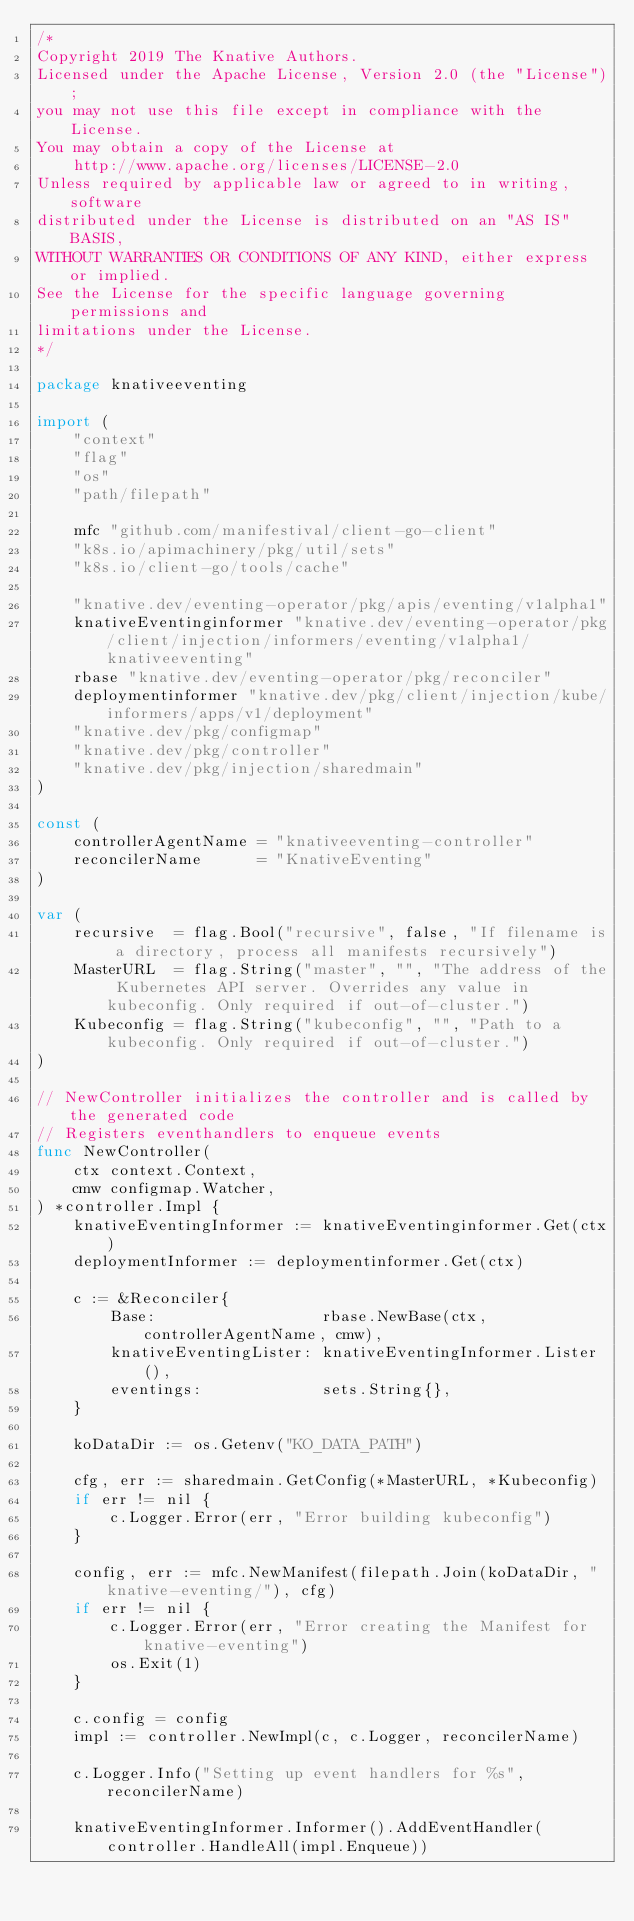Convert code to text. <code><loc_0><loc_0><loc_500><loc_500><_Go_>/*
Copyright 2019 The Knative Authors.
Licensed under the Apache License, Version 2.0 (the "License");
you may not use this file except in compliance with the License.
You may obtain a copy of the License at
    http://www.apache.org/licenses/LICENSE-2.0
Unless required by applicable law or agreed to in writing, software
distributed under the License is distributed on an "AS IS" BASIS,
WITHOUT WARRANTIES OR CONDITIONS OF ANY KIND, either express or implied.
See the License for the specific language governing permissions and
limitations under the License.
*/

package knativeeventing

import (
	"context"
	"flag"
	"os"
	"path/filepath"

	mfc "github.com/manifestival/client-go-client"
	"k8s.io/apimachinery/pkg/util/sets"
	"k8s.io/client-go/tools/cache"

	"knative.dev/eventing-operator/pkg/apis/eventing/v1alpha1"
	knativeEventinginformer "knative.dev/eventing-operator/pkg/client/injection/informers/eventing/v1alpha1/knativeeventing"
	rbase "knative.dev/eventing-operator/pkg/reconciler"
	deploymentinformer "knative.dev/pkg/client/injection/kube/informers/apps/v1/deployment"
	"knative.dev/pkg/configmap"
	"knative.dev/pkg/controller"
	"knative.dev/pkg/injection/sharedmain"
)

const (
	controllerAgentName = "knativeeventing-controller"
	reconcilerName      = "KnativeEventing"
)

var (
	recursive  = flag.Bool("recursive", false, "If filename is a directory, process all manifests recursively")
	MasterURL  = flag.String("master", "", "The address of the Kubernetes API server. Overrides any value in kubeconfig. Only required if out-of-cluster.")
	Kubeconfig = flag.String("kubeconfig", "", "Path to a kubeconfig. Only required if out-of-cluster.")
)

// NewController initializes the controller and is called by the generated code
// Registers eventhandlers to enqueue events
func NewController(
	ctx context.Context,
	cmw configmap.Watcher,
) *controller.Impl {
	knativeEventingInformer := knativeEventinginformer.Get(ctx)
	deploymentInformer := deploymentinformer.Get(ctx)

	c := &Reconciler{
		Base:                  rbase.NewBase(ctx, controllerAgentName, cmw),
		knativeEventingLister: knativeEventingInformer.Lister(),
		eventings:             sets.String{},
	}

	koDataDir := os.Getenv("KO_DATA_PATH")

	cfg, err := sharedmain.GetConfig(*MasterURL, *Kubeconfig)
	if err != nil {
		c.Logger.Error(err, "Error building kubeconfig")
	}

	config, err := mfc.NewManifest(filepath.Join(koDataDir, "knative-eventing/"), cfg)
	if err != nil {
		c.Logger.Error(err, "Error creating the Manifest for knative-eventing")
		os.Exit(1)
	}

	c.config = config
	impl := controller.NewImpl(c, c.Logger, reconcilerName)

	c.Logger.Info("Setting up event handlers for %s", reconcilerName)

	knativeEventingInformer.Informer().AddEventHandler(controller.HandleAll(impl.Enqueue))
</code> 